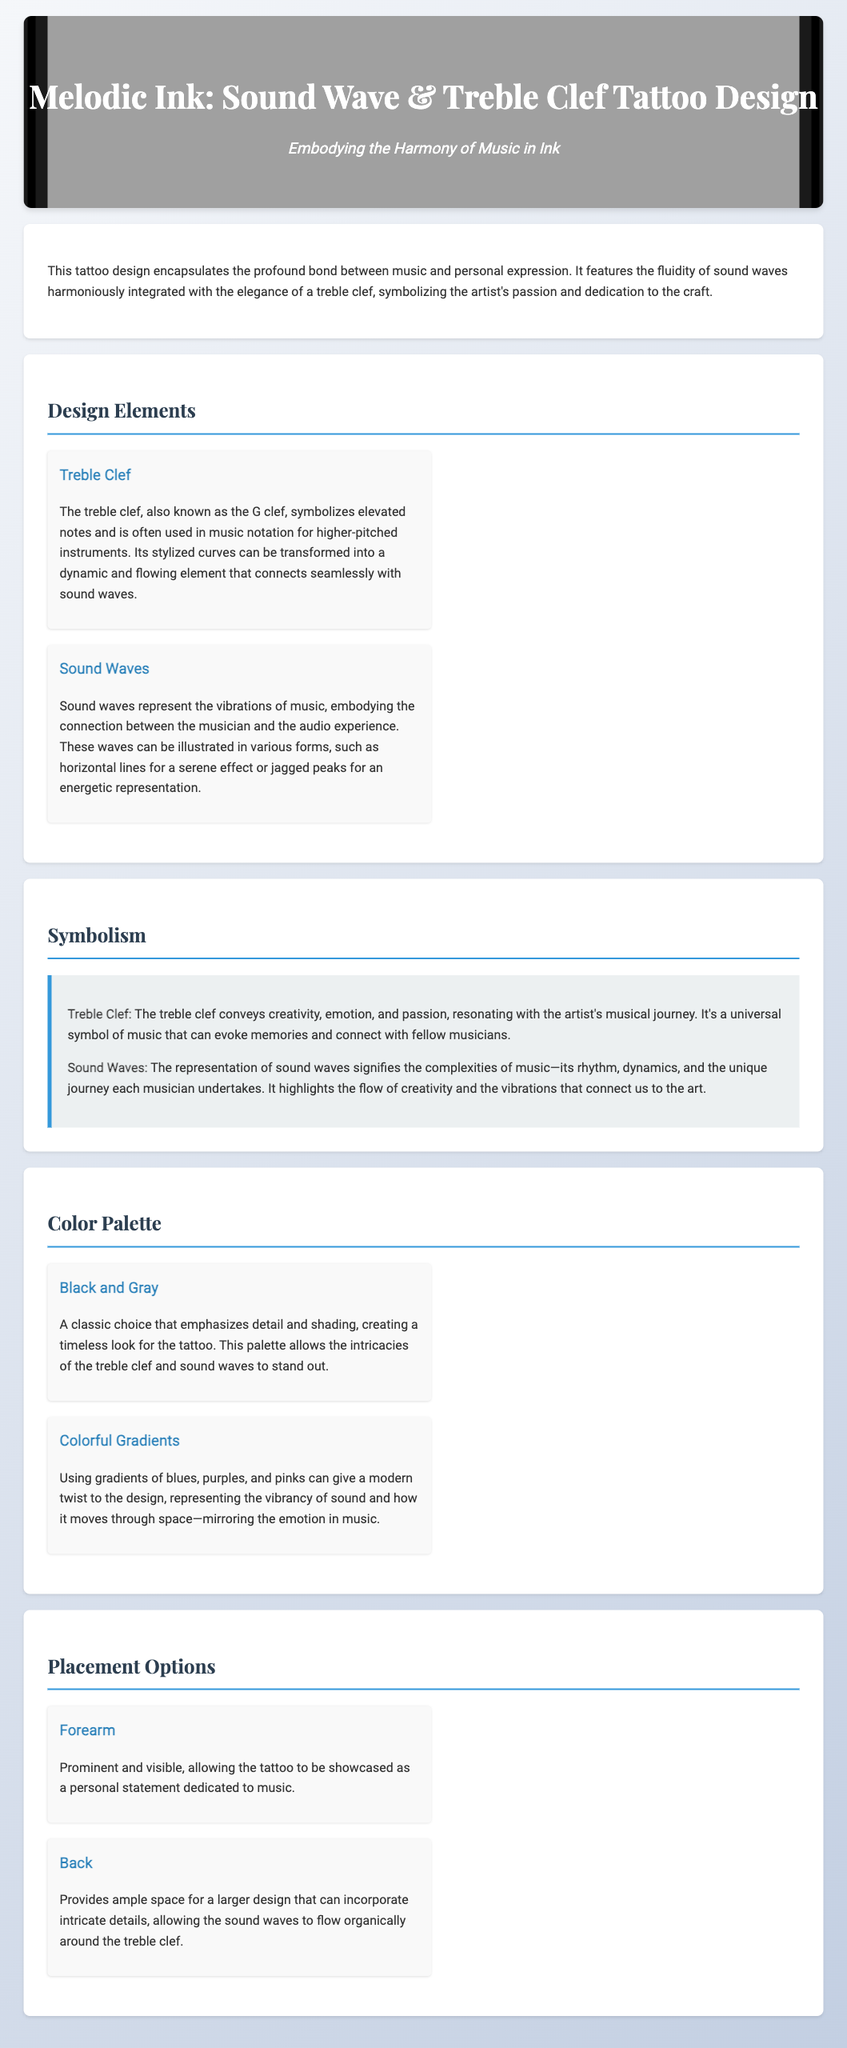What is the title of the document? The title is located in the header of the document and indicates the subject matter.
Answer: Melodic Ink: Sound Wave & Treble Clef Tattoo Design What two elements are featured in the design? The design elements are outlined in the section dedicated to them, highlighting the key components of the tattoo.
Answer: Treble Clef and Sound Waves What color palette emphasizes detail and shading? The color palette section lists two options, and one choice emphasizes a classic look.
Answer: Black and Gray How does the treble clef symbolize the artist's musical journey? The symbolism section explains the meanings associated with the elements of the tattoo design.
Answer: Creativity, emotion, and passion Where is one recommended placement for the tattoo? The placement options section provides locations for the tattoo, focused on visibility and personal statement.
Answer: Forearm 